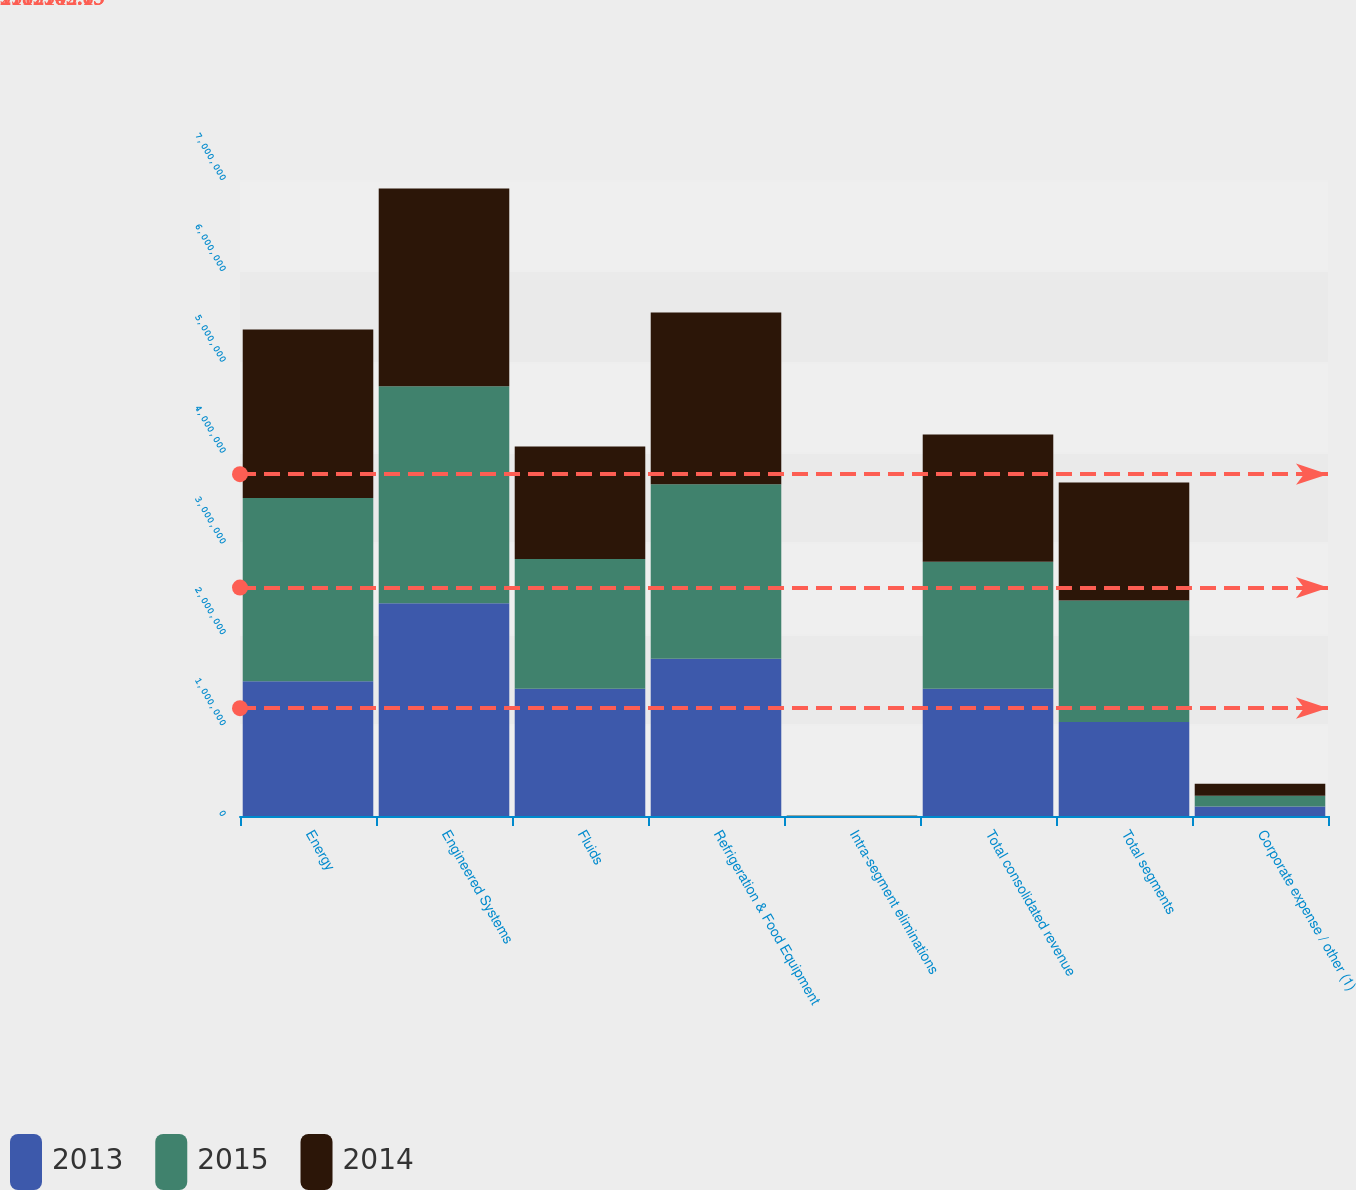Convert chart. <chart><loc_0><loc_0><loc_500><loc_500><stacked_bar_chart><ecel><fcel>Energy<fcel>Engineered Systems<fcel>Fluids<fcel>Refrigeration & Food Equipment<fcel>Intra-segment eliminations<fcel>Total consolidated revenue<fcel>Total segments<fcel>Corporate expense / other (1)<nl><fcel>2013<fcel>1.48368e+06<fcel>2.34291e+06<fcel>1.39927e+06<fcel>1.73143e+06<fcel>985<fcel>1.39927e+06<fcel>1.03357e+06<fcel>105700<nl><fcel>2015<fcel>2.01724e+06<fcel>2.38596e+06<fcel>1.43057e+06<fcel>1.92119e+06<fcel>2231<fcel>1.39927e+06<fcel>1.33919e+06<fcel>117800<nl><fcel>2014<fcel>1.85385e+06<fcel>2.17797e+06<fcel>1.23684e+06<fcel>1.88784e+06<fcel>1405<fcel>1.39927e+06<fcel>1.29898e+06<fcel>132336<nl></chart> 